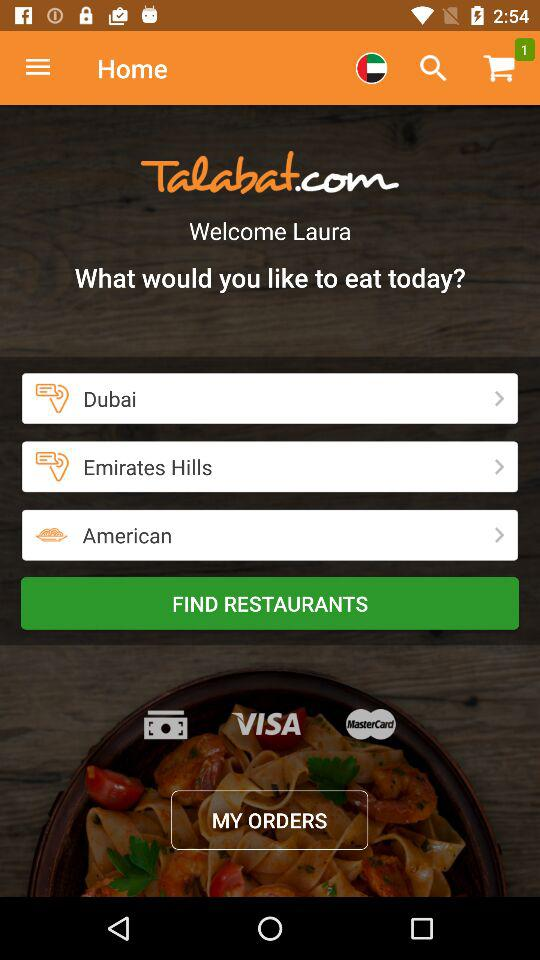What kind of food do you like to eat? The kind of food I like to eat is American. 